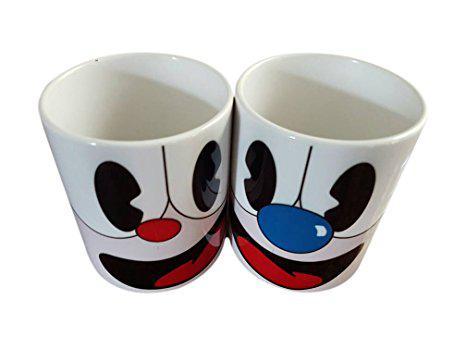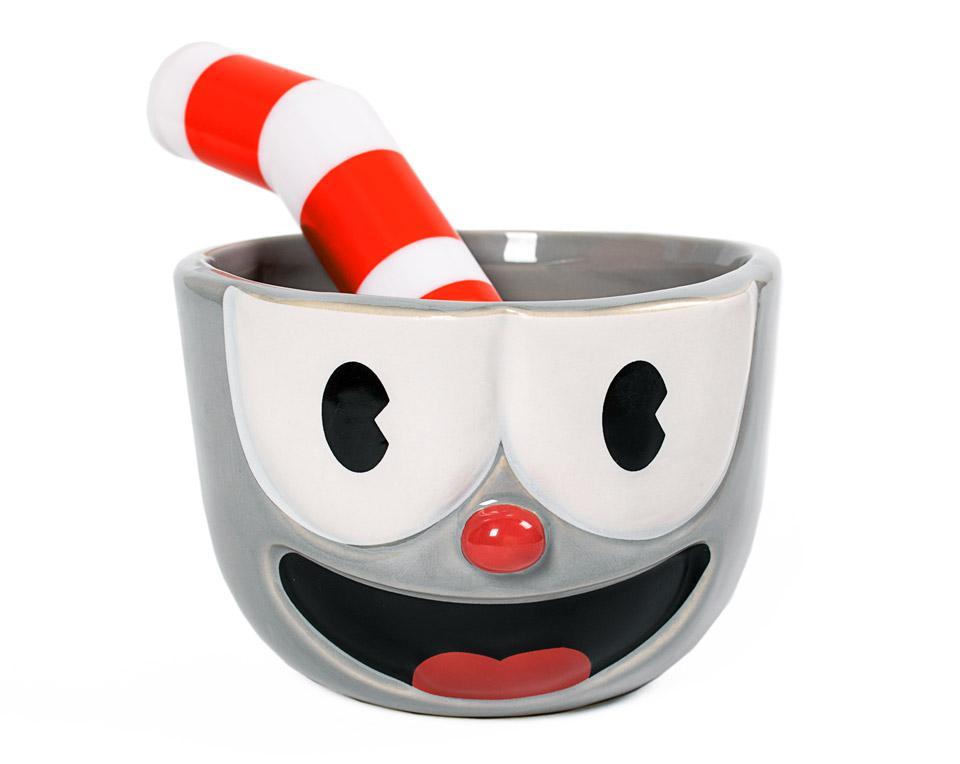The first image is the image on the left, the second image is the image on the right. Considering the images on both sides, is "An equal number of cups with a face design are in each image, a fat striped straw in each cup." valid? Answer yes or no. No. The first image is the image on the left, the second image is the image on the right. Analyze the images presented: Is the assertion "The left and right image contains the same number porcelain of smiley face cups." valid? Answer yes or no. No. 